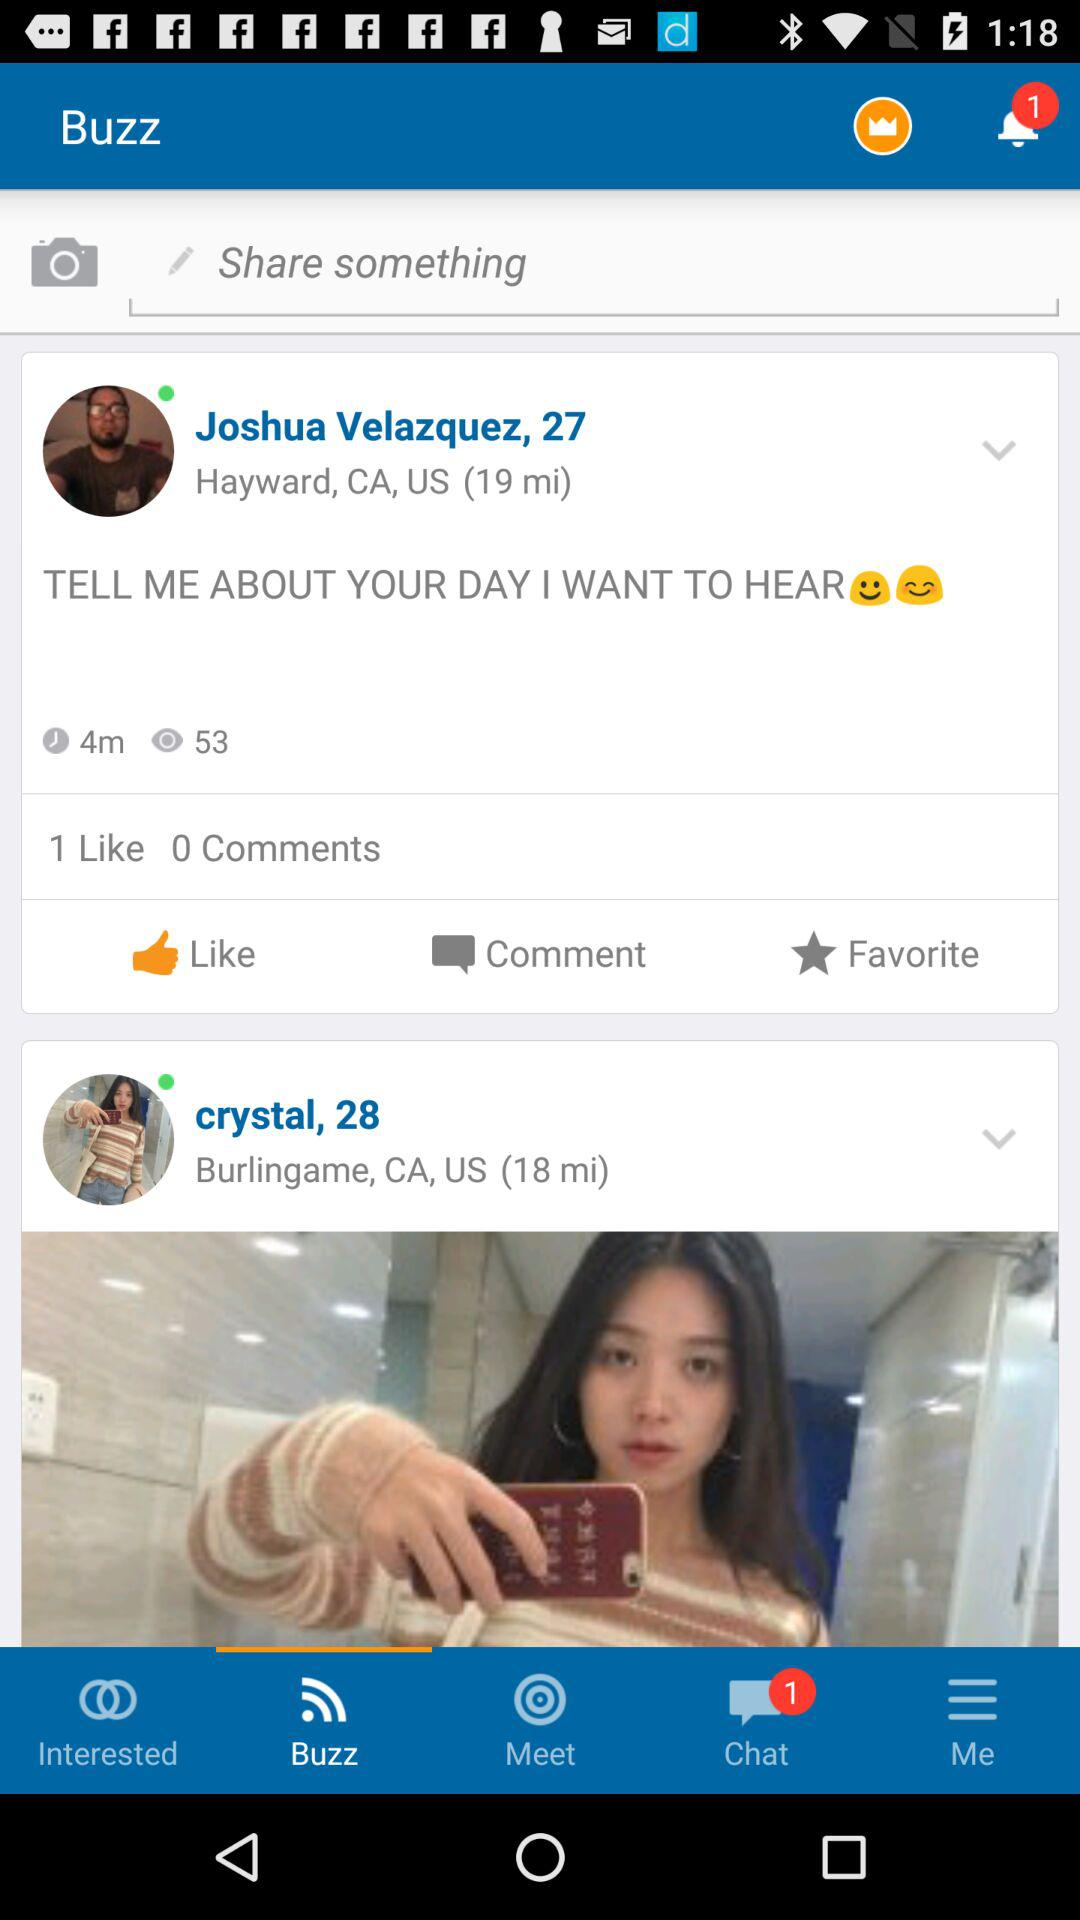How many unread chats are there? There is one unread chat. 